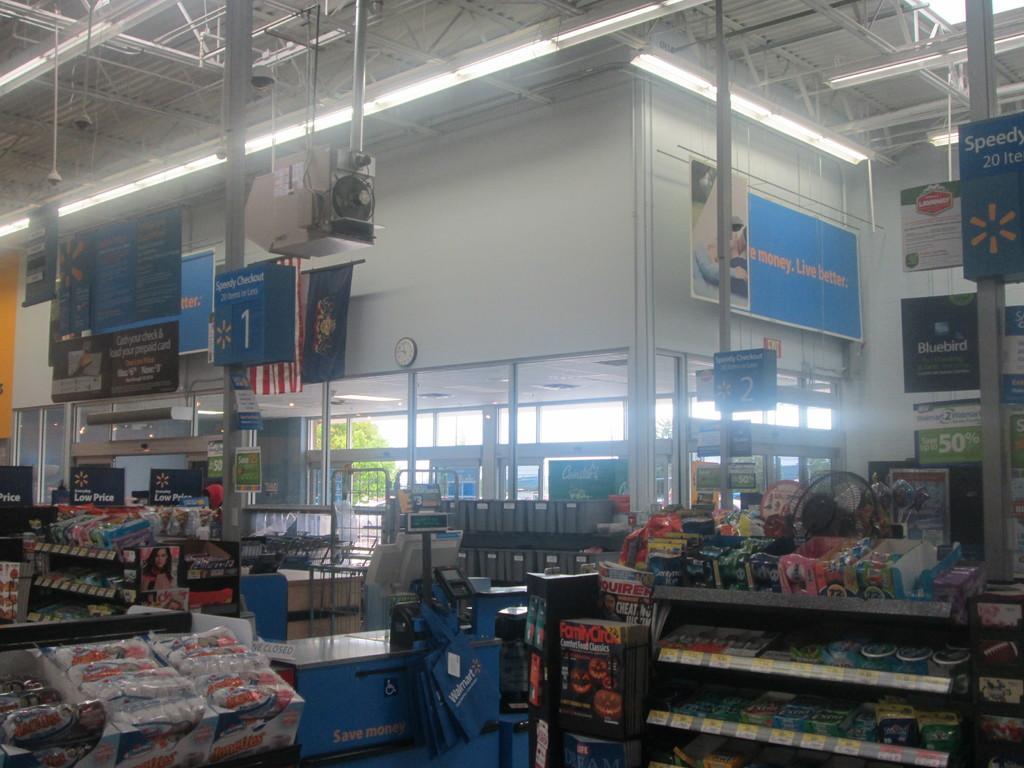Describe this image in one or two sentences. Here in this picture we can see an inside view of a store, as we can see number of food items and other items present in the rack over there and we can see hoardings present on the poles over there and we can also see machines and CCTV cameras and lights present on the roof over there and we can also see some banners present and outside the store we can see trees present in the far over there. 